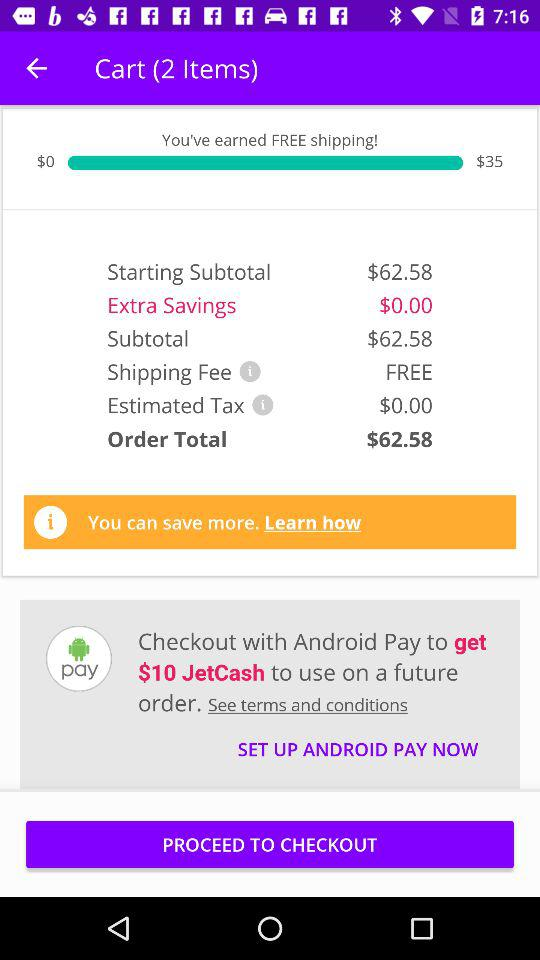How much is the "Extra Savings"? The extra savings are $0.00. 